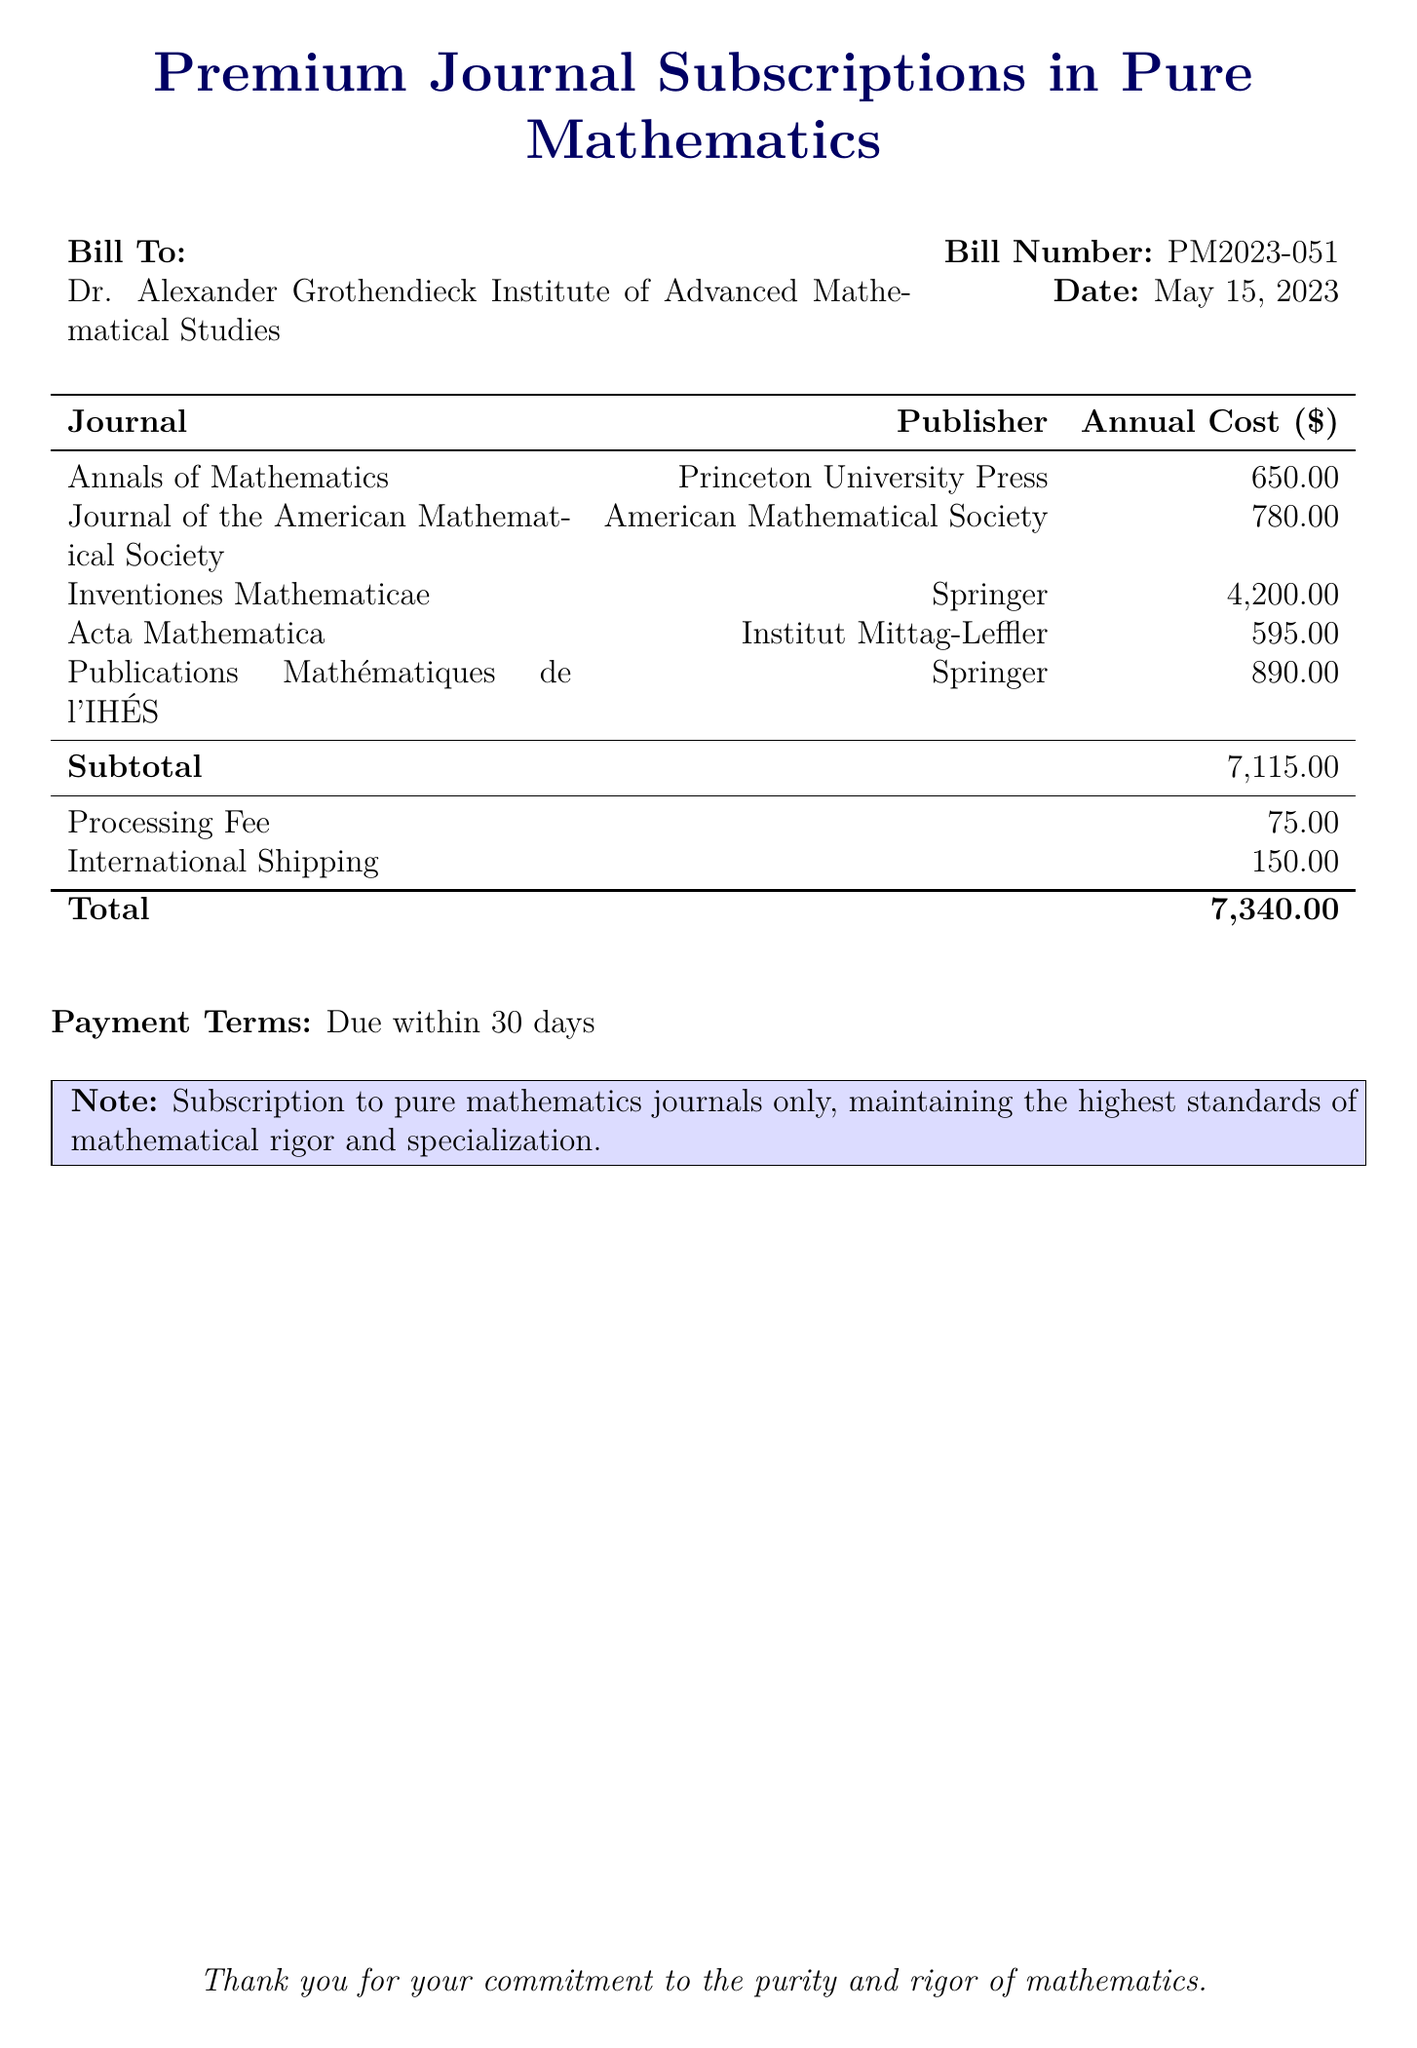What is the total cost for the subscriptions? The total cost is the sum of the subtotal, processing fee, and international shipping listed in the document. The subtotal is $7115.00, the processing fee is $75.00, and the international shipping is $150.00, leading to a total of $7340.00.
Answer: $7340.00 Who is the bill addressed to? The bill is addressed to the Dr. Alexander Grothendieck Institute of Advanced Mathematical Studies, as specified at the beginning of the document.
Answer: Dr. Alexander Grothendieck Institute of Advanced Mathematical Studies What is the date of the bill? The date of the bill is explicitly mentioned in the document, indicating when the bill was generated.
Answer: May 15, 2023 Which journal has the highest annual cost? The journal with the highest annual cost is the one listed as having a price of $4200.00, which can be found in the costs table.
Answer: Inventiones Mathematicae What is the subtotal for the journal subscriptions? The subtotal is listed in the document, calculated as the sum of all journal subscription costs before additional fees.
Answer: $7115.00 What is the processing fee listed in the bill? The processing fee is specifically indicated in the document as an additional cost to be paid.
Answer: $75.00 How many journals are listed in total? The document lists a specific number of journals under the "Journal" section, which are detailed in the table.
Answer: 5 What is stated in the payment terms section? The payment terms specify conditions for when the payment is due, indicating the timeline for transaction completion.
Answer: Due within 30 days What is the note regarding subscriptions mentioned in the document? The document includes a note emphasizing the nature of the subscriptions, highlighting the focus on rigorous mathematics.
Answer: Subscription to pure mathematics journals only, maintaining the highest standards of mathematical rigor and specialization 